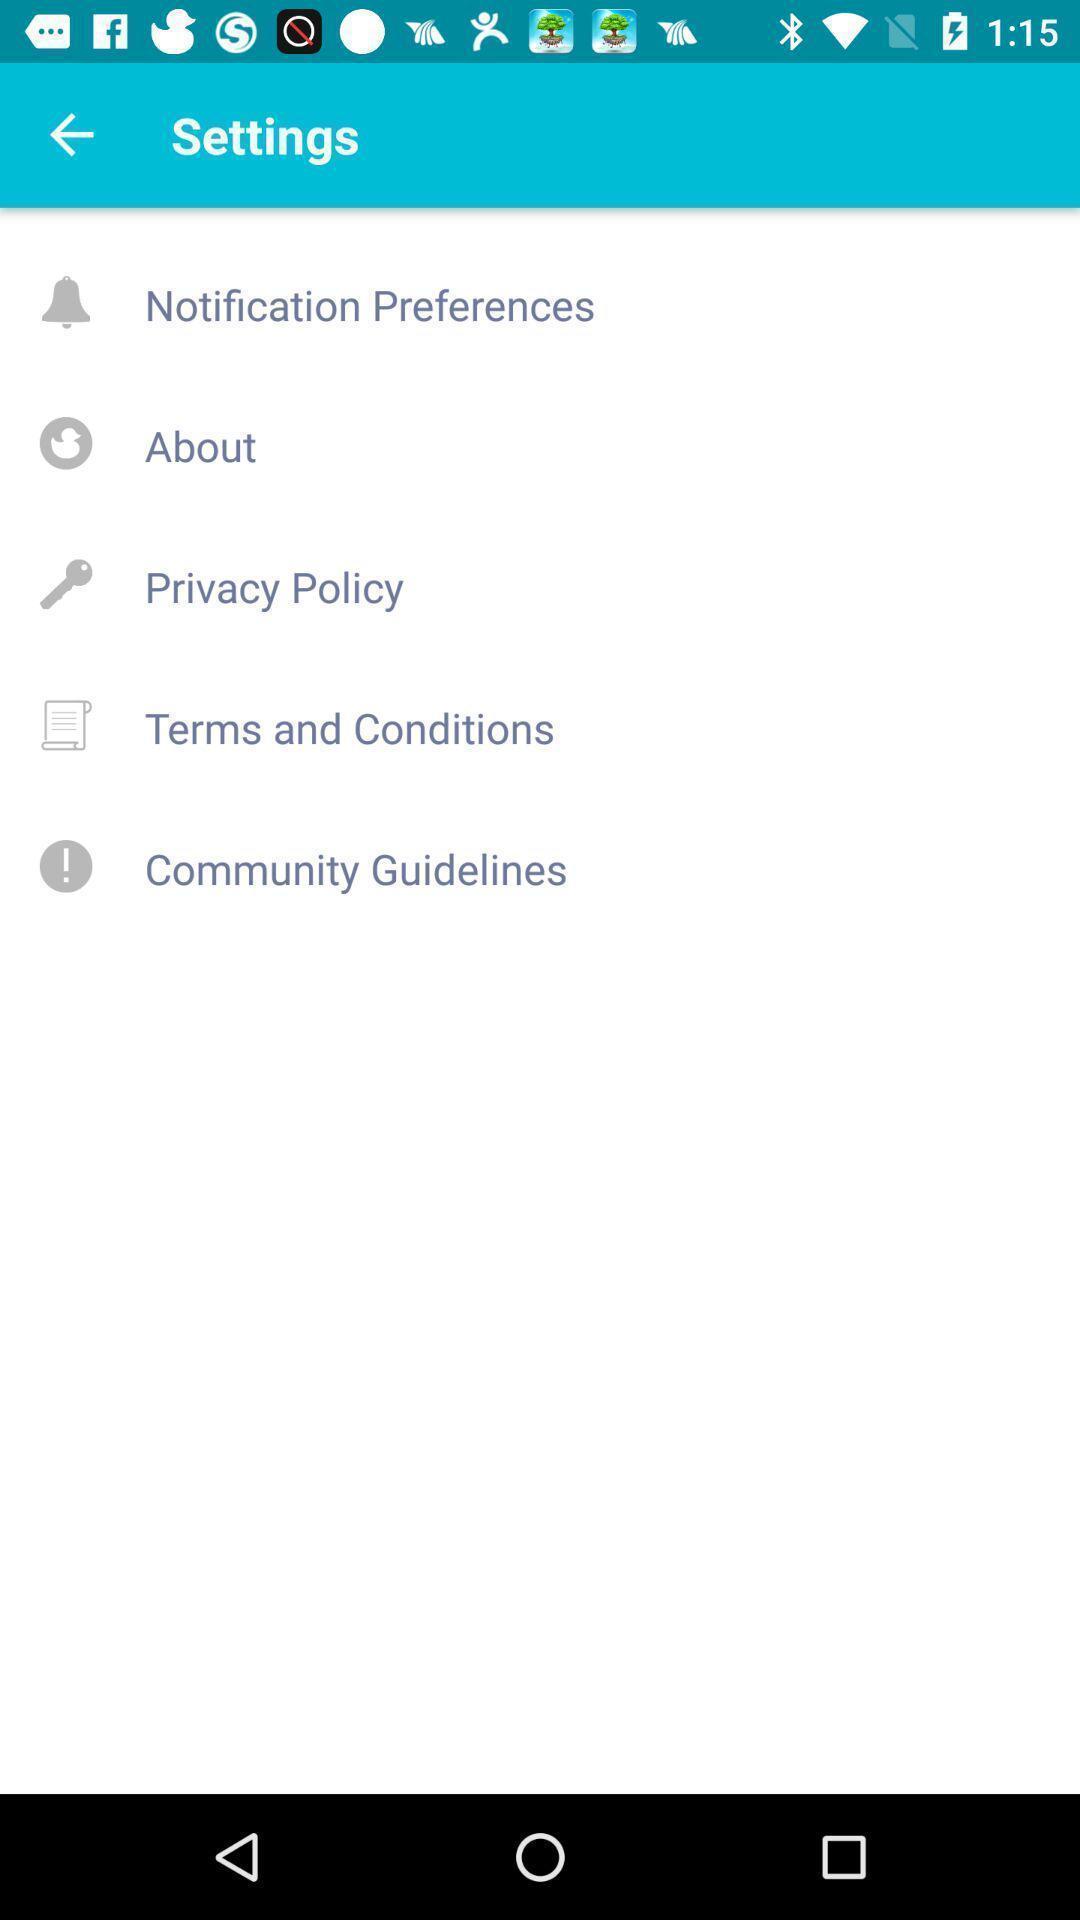Explain the elements present in this screenshot. Settings tab with different options to regulate application. 